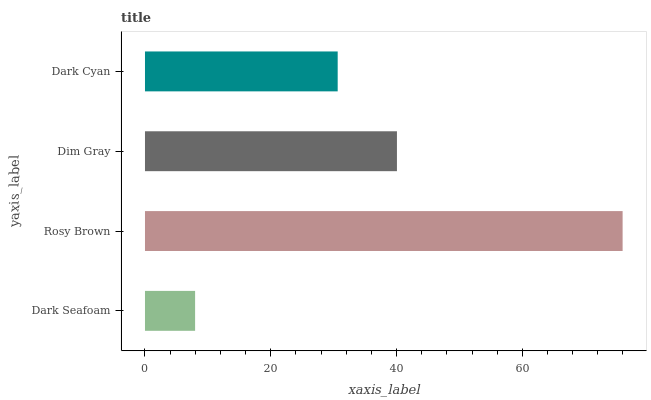Is Dark Seafoam the minimum?
Answer yes or no. Yes. Is Rosy Brown the maximum?
Answer yes or no. Yes. Is Dim Gray the minimum?
Answer yes or no. No. Is Dim Gray the maximum?
Answer yes or no. No. Is Rosy Brown greater than Dim Gray?
Answer yes or no. Yes. Is Dim Gray less than Rosy Brown?
Answer yes or no. Yes. Is Dim Gray greater than Rosy Brown?
Answer yes or no. No. Is Rosy Brown less than Dim Gray?
Answer yes or no. No. Is Dim Gray the high median?
Answer yes or no. Yes. Is Dark Cyan the low median?
Answer yes or no. Yes. Is Dark Cyan the high median?
Answer yes or no. No. Is Dark Seafoam the low median?
Answer yes or no. No. 